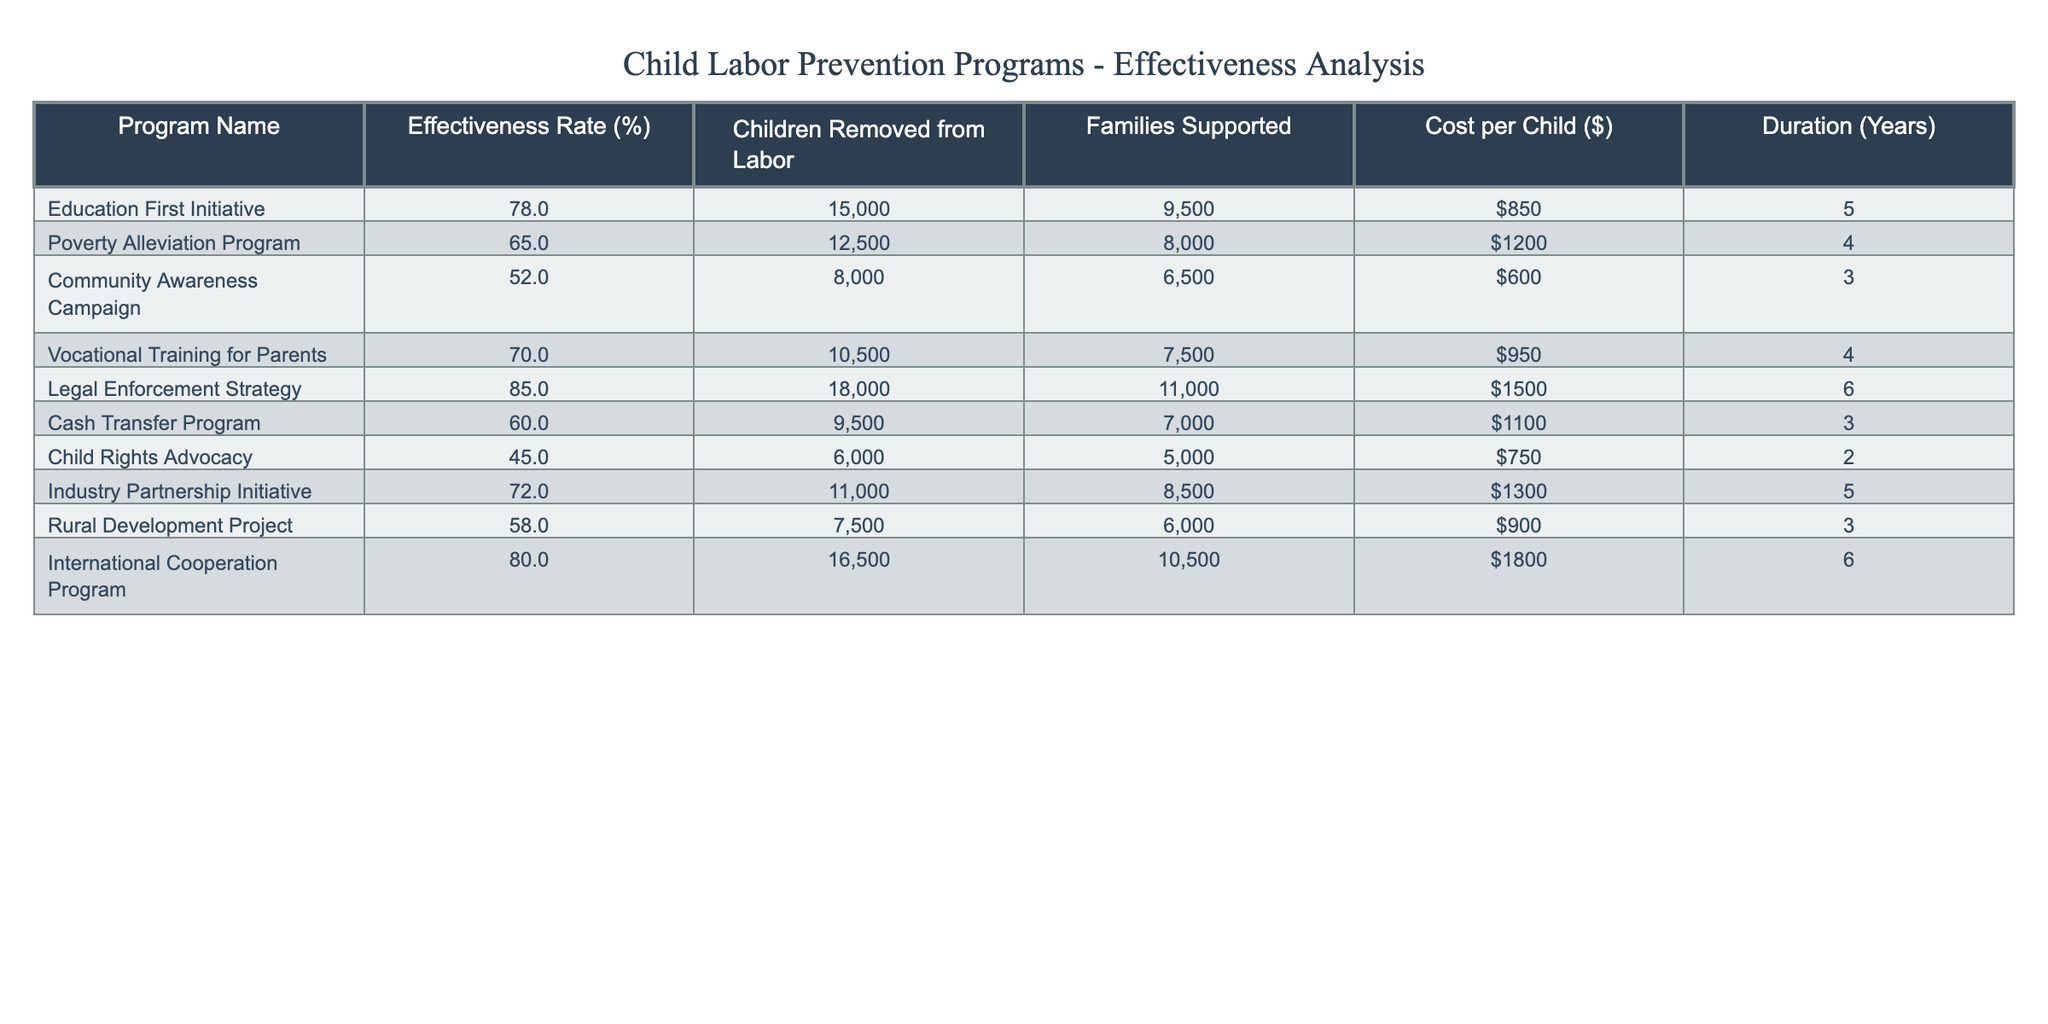What is the effectiveness rate of the Legal Enforcement Strategy? The effectiveness rate for the Legal Enforcement Strategy can be found in the table under the "Effectiveness Rate (%)" column. It shows a value of 85%.
Answer: 85% Which program removed the highest number of children from labor? The table lists the number of children removed from labor for each program, and the Legal Enforcement Strategy removed 18,000 children, which is the highest among all programs.
Answer: Legal Enforcement Strategy What is the average cost per child for all programs listed? To find the average cost per child, sum the cost per child from all programs: (850 + 1200 + 600 + 950 + 1500 + 1100 + 750 + 1300 + 900 + 1800) = 10350. There are 10 programs, so the average is 10350 / 10 = 1035.
Answer: 1035 Is the Community Awareness Campaign considered effective based on its effectiveness rate? The effectiveness rate for the Community Awareness Campaign is 52%, which indicates a moderate level of effectiveness. Generally, effectiveness is subjective, but comparatively, it is lower than most other programs.
Answer: Yes What is the total number of families supported by all programs combined? To find the total number of families supported, sum the values from the "Families Supported" column: (9500 + 8000 + 6500 + 7500 + 11000 + 7000 + 5000 + 8500 + 6000 + 10500) = 78000.
Answer: 78000 How many programs have an effectiveness rate of 70% or higher? Looking at the effectiveness rates, the programs with rates of 70% or higher are the Education First Initiative (78%), Vocational Training for Parents (70%), Legal Enforcement Strategy (85%), and International Cooperation Program (80%). Thus, there are 4 programs that meet this criterion.
Answer: 4 If we rank the programs from highest to lowest effectiveness rate, what is the effectiveness rate of the program in the third position? The rankings of effectiveness rates from highest to lowest are: Legal Enforcement Strategy (85%), International Cooperation Program (80%), Education First Initiative (78%), and then the next is Industry Partnership Initiative (72%). The third position is the Education First Initiative with an effectiveness rate of 78%.
Answer: 78% What is the cost difference between the program with the highest effectiveness rate and the program with the lowest effectiveness rate? The highest effectiveness rate is for the Legal Enforcement Strategy (85%) which has a cost of $1500 per child, while the lowest is for Child Rights Advocacy (45%) with a cost of $750 per child. The difference is 1500 - 750 = 750 dollars.
Answer: 750 